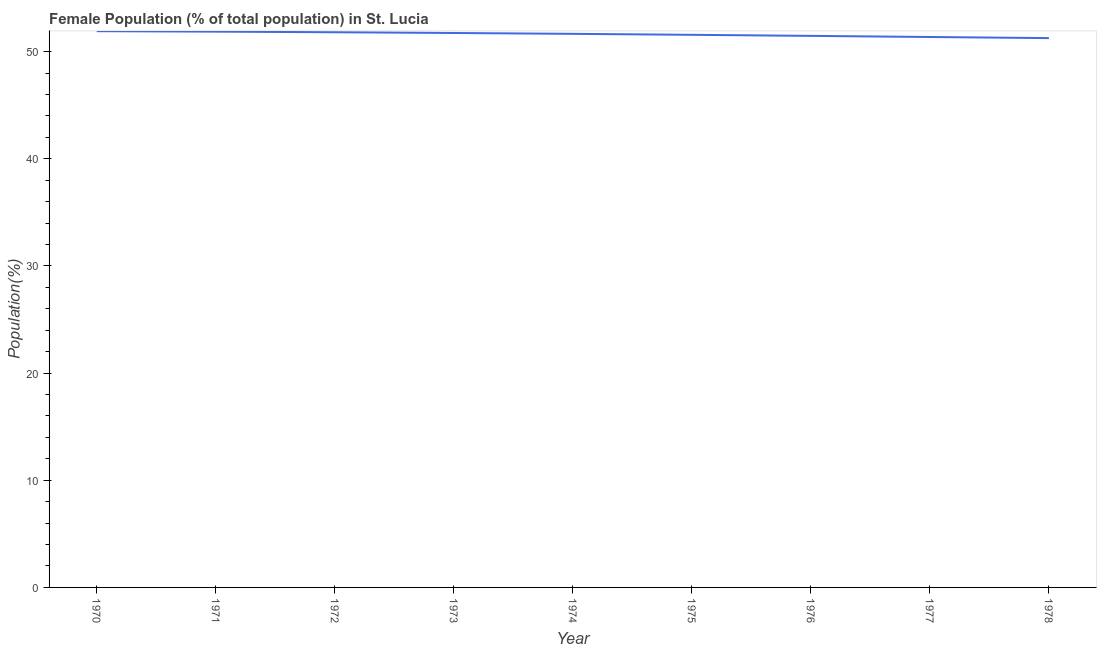What is the female population in 1975?
Provide a succinct answer. 51.57. Across all years, what is the maximum female population?
Offer a terse response. 51.91. Across all years, what is the minimum female population?
Ensure brevity in your answer.  51.26. In which year was the female population maximum?
Provide a succinct answer. 1970. In which year was the female population minimum?
Make the answer very short. 1978. What is the sum of the female population?
Keep it short and to the point. 464.63. What is the difference between the female population in 1974 and 1978?
Your answer should be compact. 0.4. What is the average female population per year?
Give a very brief answer. 51.63. What is the median female population?
Give a very brief answer. 51.66. In how many years, is the female population greater than 2 %?
Your answer should be very brief. 9. Do a majority of the years between 1975 and 1977 (inclusive) have female population greater than 28 %?
Ensure brevity in your answer.  Yes. What is the ratio of the female population in 1974 to that in 1977?
Make the answer very short. 1.01. Is the female population in 1971 less than that in 1973?
Give a very brief answer. No. Is the difference between the female population in 1971 and 1973 greater than the difference between any two years?
Provide a succinct answer. No. What is the difference between the highest and the second highest female population?
Your answer should be very brief. 0.04. Is the sum of the female population in 1974 and 1976 greater than the maximum female population across all years?
Make the answer very short. Yes. What is the difference between the highest and the lowest female population?
Your answer should be compact. 0.65. Does the female population monotonically increase over the years?
Ensure brevity in your answer.  No. How many lines are there?
Your answer should be very brief. 1. Are the values on the major ticks of Y-axis written in scientific E-notation?
Your answer should be very brief. No. Does the graph contain grids?
Ensure brevity in your answer.  No. What is the title of the graph?
Your answer should be very brief. Female Population (% of total population) in St. Lucia. What is the label or title of the X-axis?
Your answer should be compact. Year. What is the label or title of the Y-axis?
Offer a terse response. Population(%). What is the Population(%) in 1970?
Make the answer very short. 51.91. What is the Population(%) in 1971?
Your answer should be very brief. 51.86. What is the Population(%) of 1972?
Ensure brevity in your answer.  51.81. What is the Population(%) in 1973?
Your response must be concise. 51.74. What is the Population(%) in 1974?
Offer a very short reply. 51.66. What is the Population(%) in 1975?
Provide a short and direct response. 51.57. What is the Population(%) in 1976?
Your answer should be compact. 51.47. What is the Population(%) in 1977?
Provide a succinct answer. 51.36. What is the Population(%) in 1978?
Offer a terse response. 51.26. What is the difference between the Population(%) in 1970 and 1971?
Keep it short and to the point. 0.04. What is the difference between the Population(%) in 1970 and 1972?
Offer a very short reply. 0.1. What is the difference between the Population(%) in 1970 and 1973?
Make the answer very short. 0.17. What is the difference between the Population(%) in 1970 and 1974?
Provide a short and direct response. 0.25. What is the difference between the Population(%) in 1970 and 1975?
Keep it short and to the point. 0.34. What is the difference between the Population(%) in 1970 and 1976?
Offer a very short reply. 0.44. What is the difference between the Population(%) in 1970 and 1977?
Keep it short and to the point. 0.54. What is the difference between the Population(%) in 1970 and 1978?
Make the answer very short. 0.65. What is the difference between the Population(%) in 1971 and 1972?
Provide a short and direct response. 0.06. What is the difference between the Population(%) in 1971 and 1973?
Your answer should be very brief. 0.13. What is the difference between the Population(%) in 1971 and 1974?
Your answer should be compact. 0.21. What is the difference between the Population(%) in 1971 and 1975?
Provide a succinct answer. 0.3. What is the difference between the Population(%) in 1971 and 1976?
Give a very brief answer. 0.4. What is the difference between the Population(%) in 1971 and 1977?
Give a very brief answer. 0.5. What is the difference between the Population(%) in 1971 and 1978?
Your answer should be very brief. 0.6. What is the difference between the Population(%) in 1972 and 1973?
Provide a short and direct response. 0.07. What is the difference between the Population(%) in 1972 and 1974?
Offer a very short reply. 0.15. What is the difference between the Population(%) in 1972 and 1975?
Ensure brevity in your answer.  0.24. What is the difference between the Population(%) in 1972 and 1976?
Ensure brevity in your answer.  0.34. What is the difference between the Population(%) in 1972 and 1977?
Your answer should be very brief. 0.44. What is the difference between the Population(%) in 1972 and 1978?
Offer a terse response. 0.55. What is the difference between the Population(%) in 1973 and 1974?
Provide a short and direct response. 0.08. What is the difference between the Population(%) in 1973 and 1975?
Your response must be concise. 0.17. What is the difference between the Population(%) in 1973 and 1976?
Make the answer very short. 0.27. What is the difference between the Population(%) in 1973 and 1977?
Provide a succinct answer. 0.37. What is the difference between the Population(%) in 1973 and 1978?
Offer a terse response. 0.48. What is the difference between the Population(%) in 1974 and 1975?
Ensure brevity in your answer.  0.09. What is the difference between the Population(%) in 1974 and 1976?
Offer a very short reply. 0.19. What is the difference between the Population(%) in 1974 and 1977?
Your answer should be very brief. 0.29. What is the difference between the Population(%) in 1974 and 1978?
Make the answer very short. 0.4. What is the difference between the Population(%) in 1975 and 1976?
Give a very brief answer. 0.1. What is the difference between the Population(%) in 1975 and 1977?
Keep it short and to the point. 0.2. What is the difference between the Population(%) in 1975 and 1978?
Offer a terse response. 0.31. What is the difference between the Population(%) in 1976 and 1977?
Your response must be concise. 0.11. What is the difference between the Population(%) in 1976 and 1978?
Offer a terse response. 0.21. What is the difference between the Population(%) in 1977 and 1978?
Keep it short and to the point. 0.1. What is the ratio of the Population(%) in 1970 to that in 1972?
Your answer should be compact. 1. What is the ratio of the Population(%) in 1970 to that in 1973?
Give a very brief answer. 1. What is the ratio of the Population(%) in 1970 to that in 1975?
Offer a terse response. 1.01. What is the ratio of the Population(%) in 1970 to that in 1976?
Your response must be concise. 1.01. What is the ratio of the Population(%) in 1970 to that in 1978?
Your answer should be very brief. 1.01. What is the ratio of the Population(%) in 1971 to that in 1973?
Offer a very short reply. 1. What is the ratio of the Population(%) in 1971 to that in 1974?
Your response must be concise. 1. What is the ratio of the Population(%) in 1971 to that in 1976?
Your answer should be very brief. 1.01. What is the ratio of the Population(%) in 1972 to that in 1975?
Ensure brevity in your answer.  1. What is the ratio of the Population(%) in 1972 to that in 1976?
Provide a short and direct response. 1.01. What is the ratio of the Population(%) in 1972 to that in 1978?
Offer a very short reply. 1.01. What is the ratio of the Population(%) in 1973 to that in 1974?
Your response must be concise. 1. What is the ratio of the Population(%) in 1973 to that in 1975?
Make the answer very short. 1. What is the ratio of the Population(%) in 1974 to that in 1975?
Ensure brevity in your answer.  1. What is the ratio of the Population(%) in 1974 to that in 1977?
Your response must be concise. 1.01. What is the ratio of the Population(%) in 1975 to that in 1976?
Offer a very short reply. 1. What is the ratio of the Population(%) in 1975 to that in 1977?
Your answer should be very brief. 1. What is the ratio of the Population(%) in 1975 to that in 1978?
Give a very brief answer. 1.01. What is the ratio of the Population(%) in 1976 to that in 1977?
Offer a very short reply. 1. 